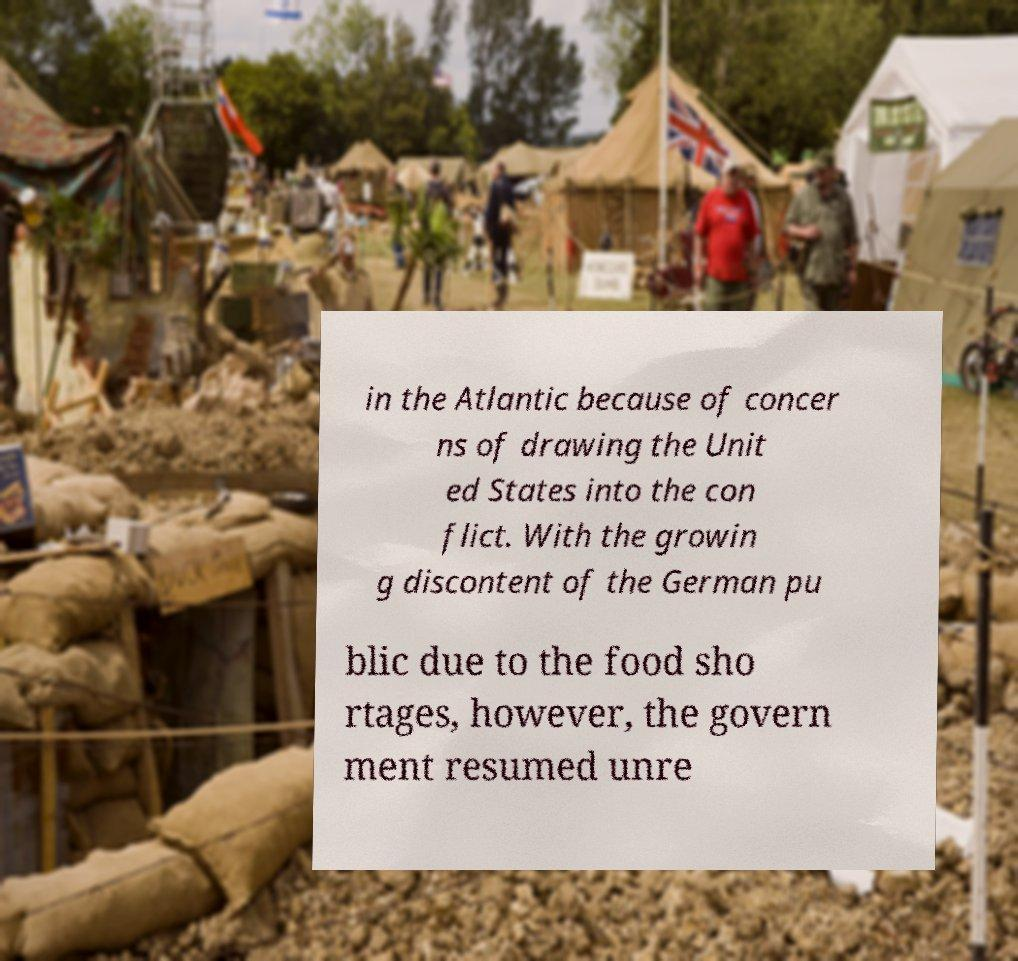Please read and relay the text visible in this image. What does it say? in the Atlantic because of concer ns of drawing the Unit ed States into the con flict. With the growin g discontent of the German pu blic due to the food sho rtages, however, the govern ment resumed unre 